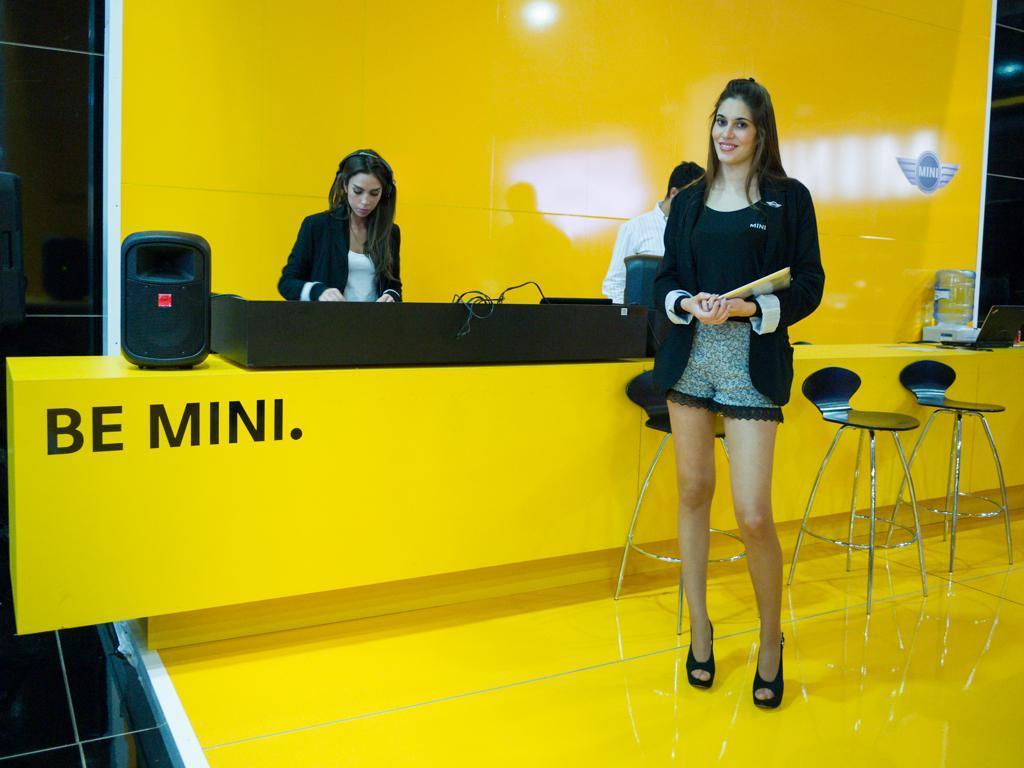Please provide a concise description of this image. This picture describe about the inside view of the mini cooper car showroom reception yellow color beautiful office in which, in front a girl is standing and smiling towards the camera and holding the file in her hand, behind there is a another girl who is standing near the reception table and on extreme right side we can see a water dispenser and in front two black color chairs. 